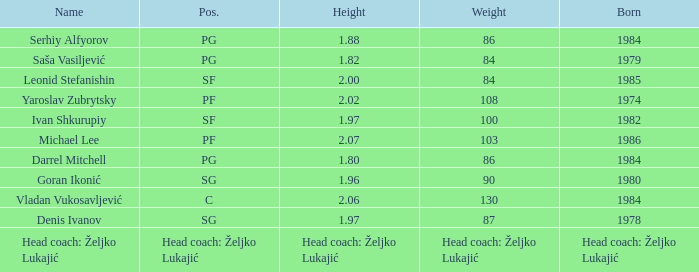What is the weight of the person born in 1980? 90.0. 